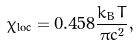<formula> <loc_0><loc_0><loc_500><loc_500>\chi _ { \text {loc} } = 0 . 4 5 8 \frac { k _ { B } T } { \pi c ^ { 2 } } ,</formula> 